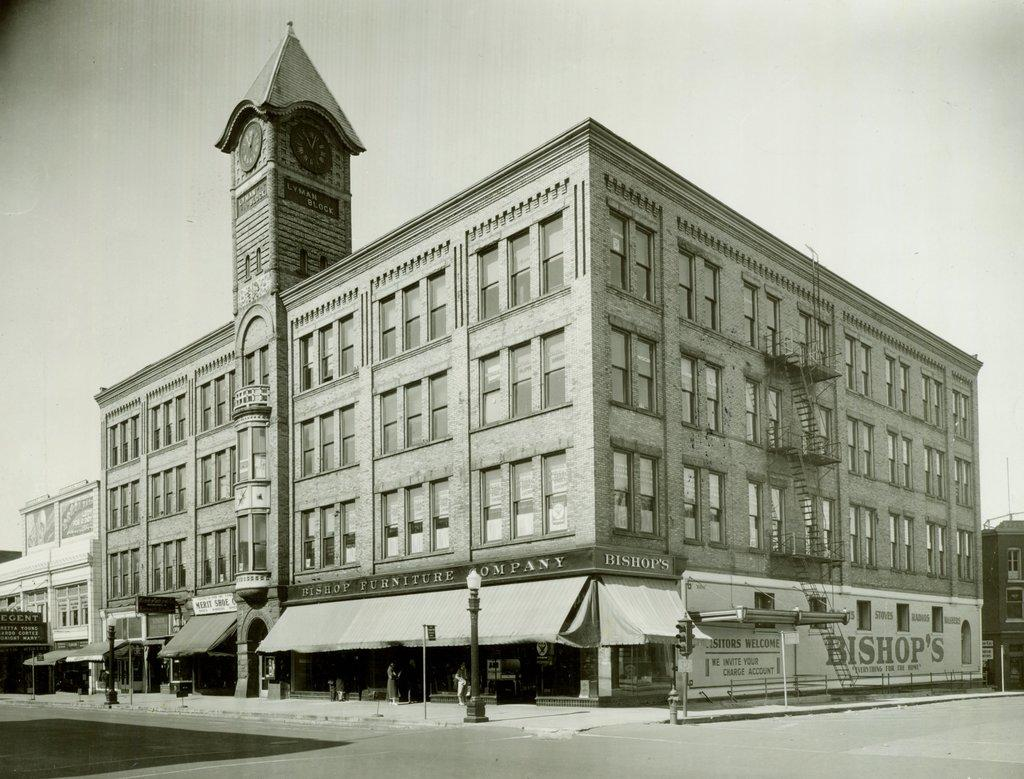What is the main structure in the picture? There is a building in the picture. What feature is attached to the tower of the building? There is a clock attached to the tower of the building. What type of lighting is present in the picture? There are poles with lamps in the picture. What is the condition of the sky in the picture? The sky is clear in the picture. What type of cracker is being used to fix the broken ray in the image? There is no cracker or broken ray present in the image. What smell can be detected in the image? There is no mention of any smell in the image. 